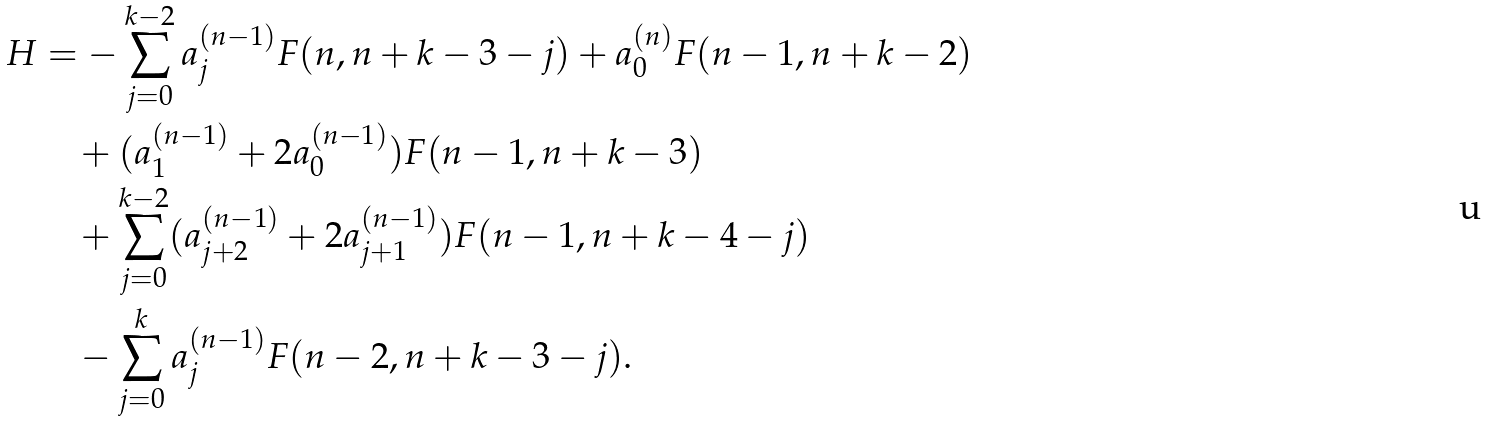Convert formula to latex. <formula><loc_0><loc_0><loc_500><loc_500>H & = - \sum _ { j = 0 } ^ { k - 2 } a _ { j } ^ { ( n - 1 ) } F ( n , n + k - 3 - j ) + a _ { 0 } ^ { ( n ) } F ( n - 1 , n + k - 2 ) \\ & \quad + ( a _ { 1 } ^ { ( n - 1 ) } + 2 a _ { 0 } ^ { ( n - 1 ) } ) F ( n - 1 , n + k - 3 ) \\ & \quad + \sum _ { j = 0 } ^ { k - 2 } ( a _ { j + 2 } ^ { ( n - 1 ) } + 2 a _ { j + 1 } ^ { ( n - 1 ) } ) F ( n - 1 , n + k - 4 - j ) \\ & \quad - \sum _ { j = 0 } ^ { k } a _ { j } ^ { ( n - 1 ) } F ( n - 2 , n + k - 3 - j ) .</formula> 